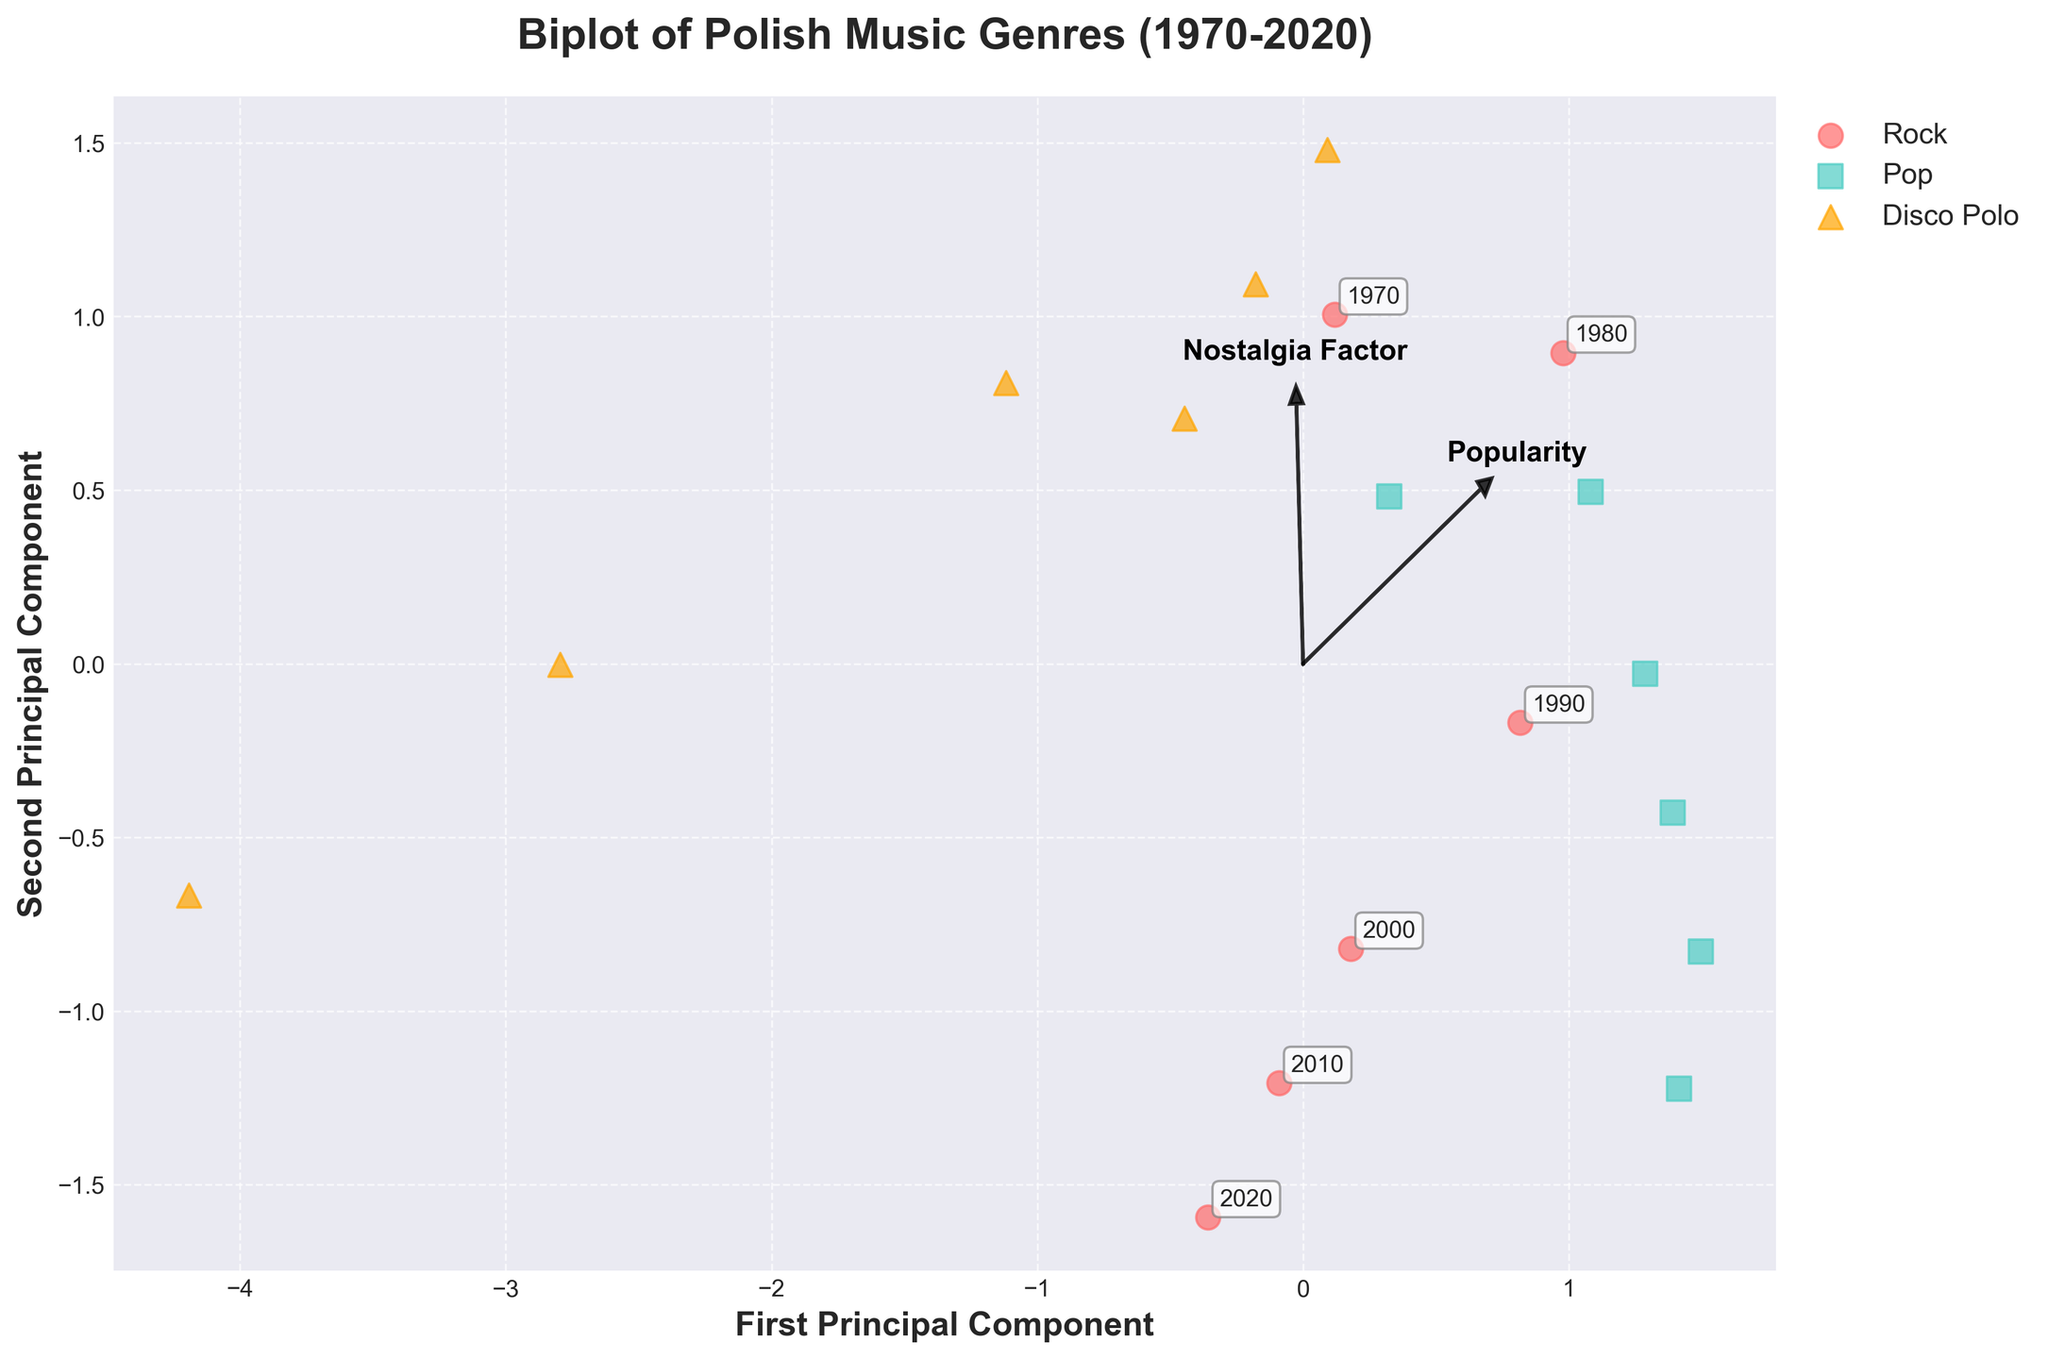What is the title of the biplot? The title is displayed at the top of the figure. It reads "Biplot of Polish Music Genres (1970-2020)".
Answer: Biplot of Polish Music Genres (1970-2020) How many music genres are compared in the biplot? There are three different colors and shapes used to represent genres: red circles for Rock, teal squares for Pop, and orange triangles for Disco Polo.
Answer: Three Which genre shows the highest popularity from 1970 to the present? By looking at the overall distribution of points, the genre with the most points to the right (higher PC1) is Pop. Higher Principal Component 1 scores are linked to higher popularity.
Answer: Pop Which component does 'Nostalgia Factor' influence more? Observe the direction and length of the feature vector. The 'Nostalgia Factor' arrow aligns more with the second principal component (PC2).
Answer: PC2 What years are annotated around the (PC1, PC2) coordinates for Rock? Each year is annotated near a red circle representing Rock. The annotations '1970', '1980', '1990', '2000', '2010', and '2020' correspondingly mark the years.
Answer: 1970, 1980, 1990, 2000, 2010, 2020 Considering Nostalgia Factor and International Influence, which genre possibly has the highest Nostalgia Factor around 2000? Check which genre occupies higher PC2 values and aligns with a point close to 2000. Disco Polo around 2000 shows a notably high PC2 (Nostalgia Factor).
Answer: Disco Polo Which genre is closest to the origin point (0,0) in the biplot? See the plotted points and determine which genre's average position is nearest the origin. Disco Polo has points relatively closer to the origin overall.
Answer: Disco Polo Which two features are most closely related across all genres, based on feature vectors' orientation? Verify which feature vectors are oriented near each other. 'Popularity' and 'International Influence' are closer to each other and align similarly.
Answer: Popularity and International Influence How does Pop's representation in the 2020s compare in terms of International Influence compared to the 1970s? Examine the teal square points in 1970 and 2020, focusing on the position along the x-axis (PC1), related to the 'International Influence' feature vector's direction. 2020 shows much higher International Influence.
Answer: Higher in 2020 Does Rock have increasing or decreasing Nostalgia Factor from 1970 to 2020? Track the movement of red circles from 1970 to 2020 along the y-axis, assessing the 'Nostalgia Factor' vector direction (towards higher PC2). It shows a general decline.
Answer: Decreasing 